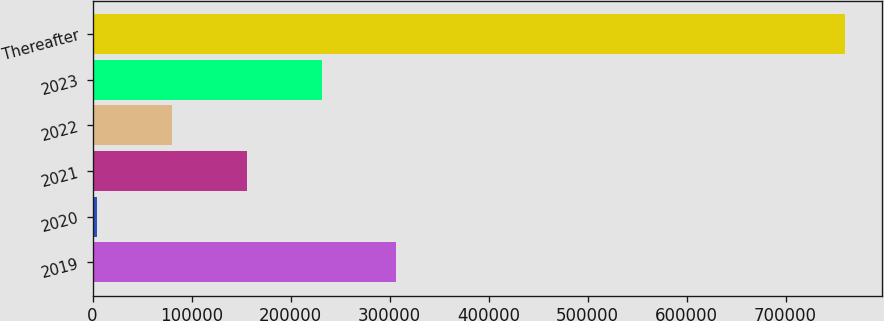Convert chart to OTSL. <chart><loc_0><loc_0><loc_500><loc_500><bar_chart><fcel>2019<fcel>2020<fcel>2021<fcel>2022<fcel>2023<fcel>Thereafter<nl><fcel>306733<fcel>4729<fcel>155731<fcel>80230.1<fcel>231232<fcel>759740<nl></chart> 